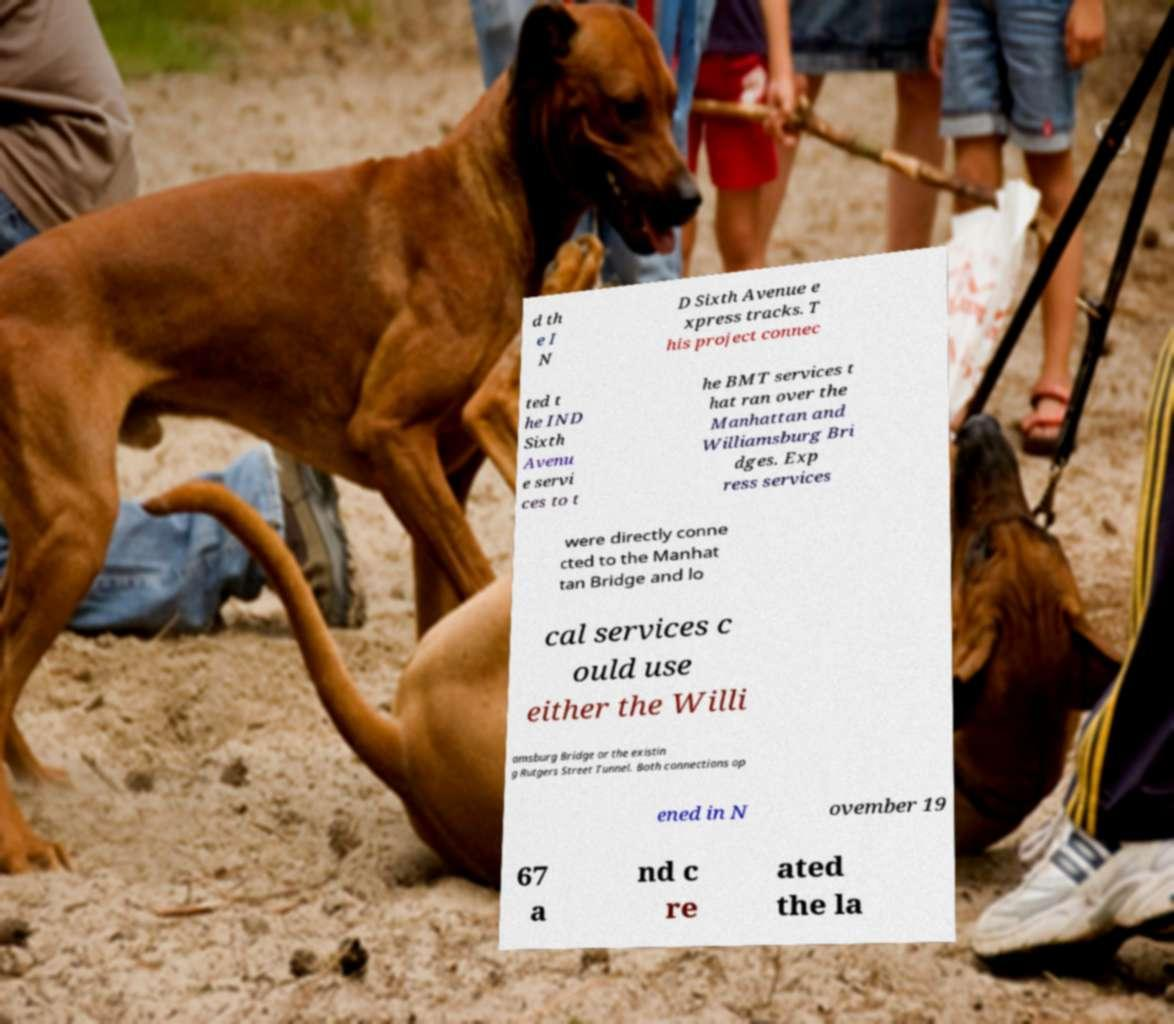There's text embedded in this image that I need extracted. Can you transcribe it verbatim? d th e I N D Sixth Avenue e xpress tracks. T his project connec ted t he IND Sixth Avenu e servi ces to t he BMT services t hat ran over the Manhattan and Williamsburg Bri dges. Exp ress services were directly conne cted to the Manhat tan Bridge and lo cal services c ould use either the Willi amsburg Bridge or the existin g Rutgers Street Tunnel. Both connections op ened in N ovember 19 67 a nd c re ated the la 